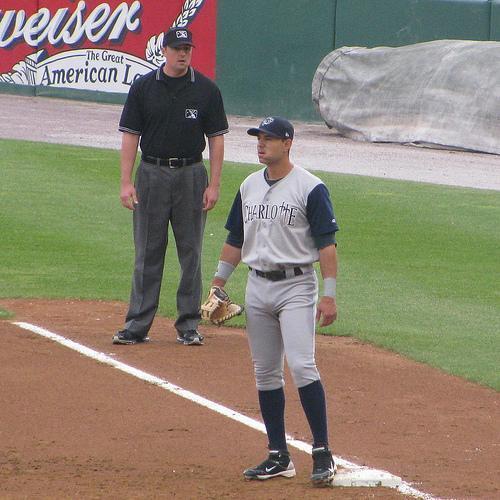How many umpires are there?
Give a very brief answer. 1. 